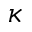<formula> <loc_0><loc_0><loc_500><loc_500>\kappa</formula> 